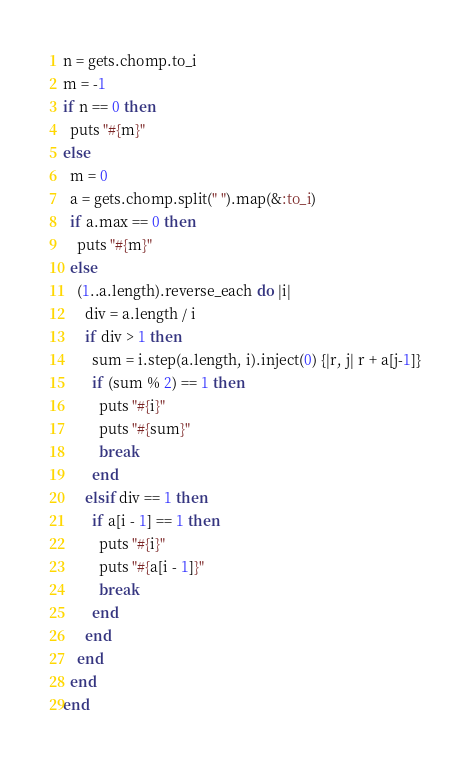Convert code to text. <code><loc_0><loc_0><loc_500><loc_500><_Ruby_>n = gets.chomp.to_i
m = -1
if n == 0 then
  puts "#{m}"
else
  m = 0
  a = gets.chomp.split(" ").map(&:to_i)
  if a.max == 0 then
    puts "#{m}"
  else
    (1..a.length).reverse_each do |i|
      div = a.length / i
      if div > 1 then
        sum = i.step(a.length, i).inject(0) {|r, j| r + a[j-1]}
        if (sum % 2) == 1 then
          puts "#{i}"
          puts "#{sum}"
          break
        end
      elsif div == 1 then
        if a[i - 1] == 1 then
          puts "#{i}"
          puts "#{a[i - 1]}"
          break
        end
      end  
    end
  end
end
</code> 